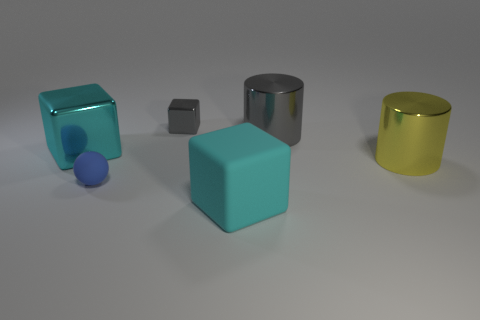Do the cyan thing that is behind the yellow cylinder and the tiny blue sphere have the same size?
Provide a succinct answer. No. Does the rubber block have the same color as the large metal block?
Offer a very short reply. Yes. Are there any other objects that have the same color as the big rubber thing?
Provide a succinct answer. Yes. The small object that is in front of the big yellow thing has what shape?
Offer a terse response. Sphere. How many cyan things are big rubber blocks or large shiny cylinders?
Provide a short and direct response. 1. There is a small thing that is the same material as the big yellow thing; what color is it?
Ensure brevity in your answer.  Gray. There is a matte cube; is it the same color as the metallic block left of the tiny matte thing?
Your response must be concise. Yes. What is the color of the object that is both to the left of the large rubber block and in front of the yellow thing?
Provide a short and direct response. Blue. How many big cyan things are to the left of the big cyan rubber object?
Make the answer very short. 1. How many objects are small blue rubber spheres or small gray shiny cubes that are behind the large gray cylinder?
Your response must be concise. 2. 